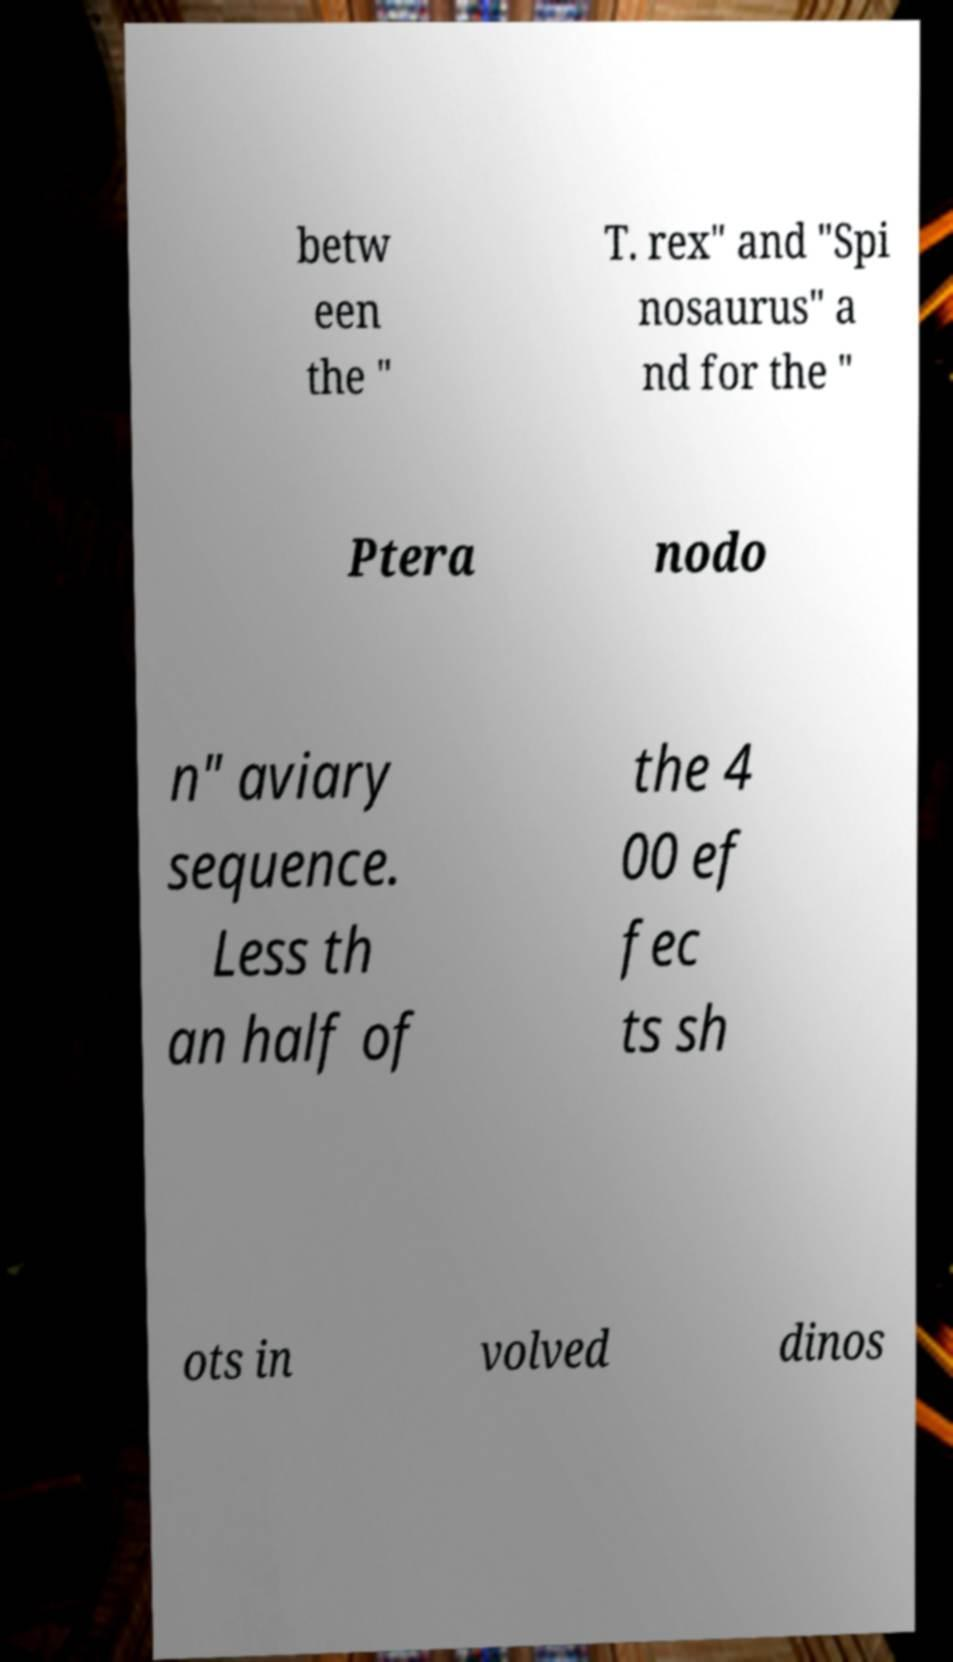Please read and relay the text visible in this image. What does it say? betw een the " T. rex" and "Spi nosaurus" a nd for the " Ptera nodo n" aviary sequence. Less th an half of the 4 00 ef fec ts sh ots in volved dinos 